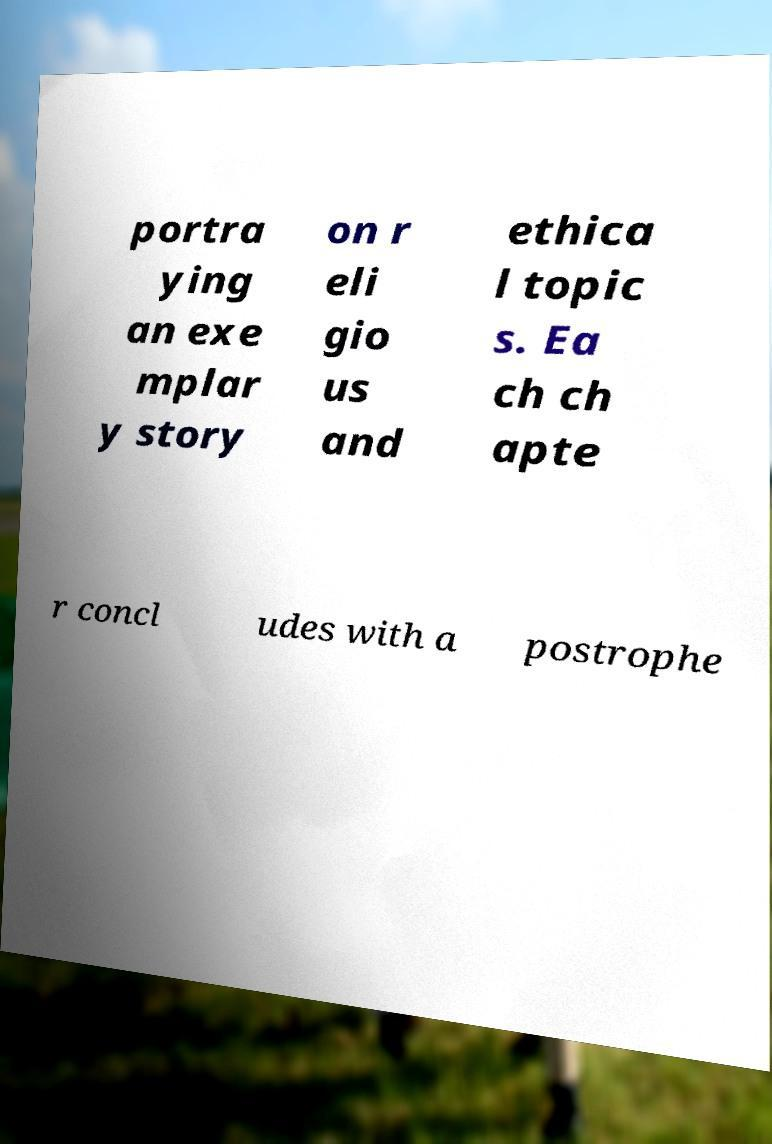Please read and relay the text visible in this image. What does it say? portra ying an exe mplar y story on r eli gio us and ethica l topic s. Ea ch ch apte r concl udes with a postrophe 